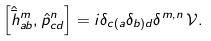<formula> <loc_0><loc_0><loc_500><loc_500>\left [ \hat { \bar { h } } ^ { m } _ { a b } , \hat { p } _ { c d } ^ { n } \right ] = i \delta _ { c ( a } \delta _ { b ) d } \delta ^ { m , n } \, \mathcal { V } .</formula> 